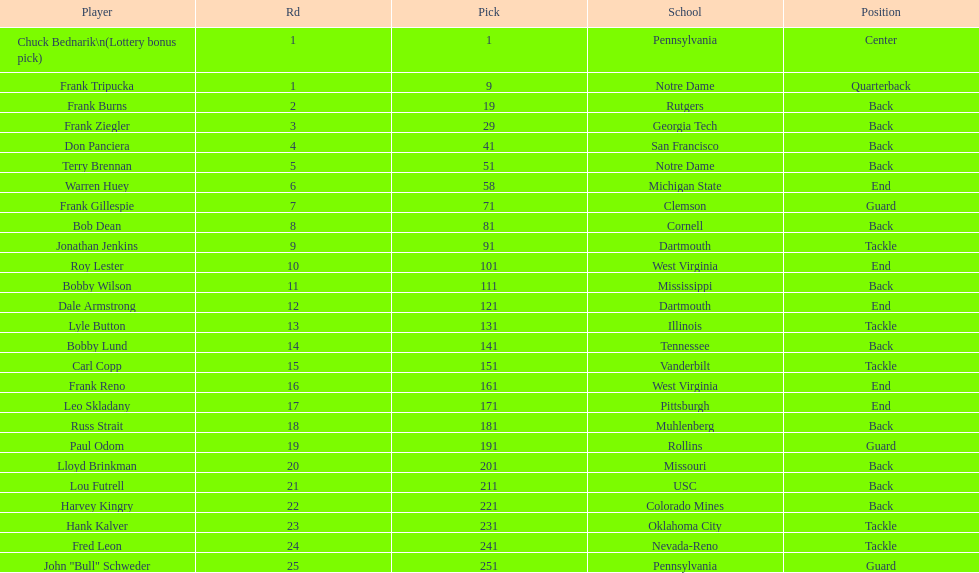Highest rd number? 25. 